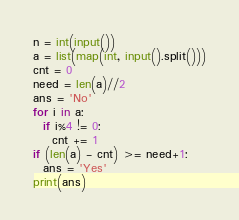<code> <loc_0><loc_0><loc_500><loc_500><_Python_>n = int(input())
a = list(map(int, input().split()))
cnt = 0
need = len(a)//2
ans = 'No'
for i in a:
  if i%4 != 0:
    cnt += 1
if (len(a) - cnt) >= need+1:
  ans = 'Yes'
print(ans)</code> 